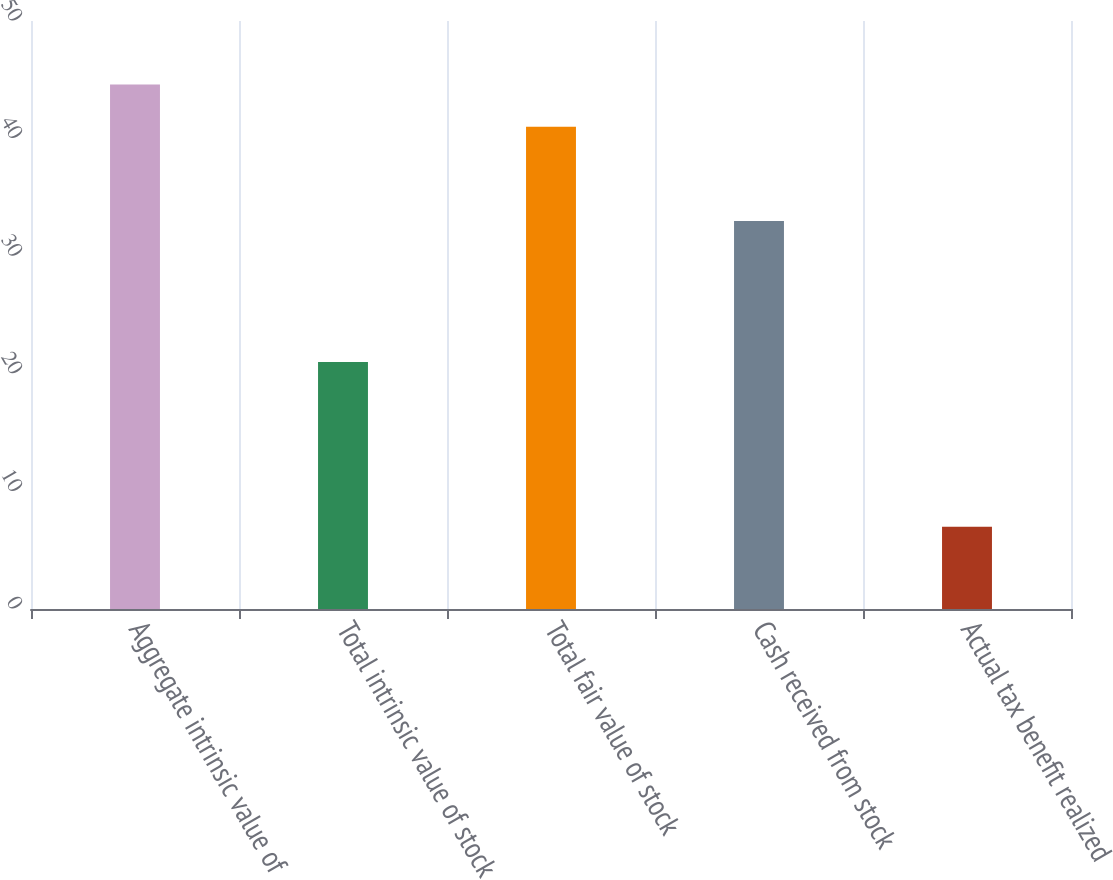<chart> <loc_0><loc_0><loc_500><loc_500><bar_chart><fcel>Aggregate intrinsic value of<fcel>Total intrinsic value of stock<fcel>Total fair value of stock<fcel>Cash received from stock<fcel>Actual tax benefit realized<nl><fcel>44.6<fcel>21<fcel>41<fcel>33<fcel>7<nl></chart> 